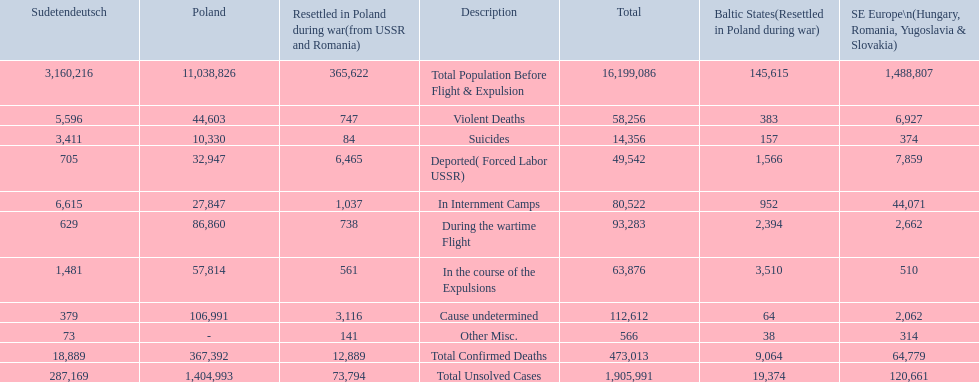What are all of the descriptions? Total Population Before Flight & Expulsion, Violent Deaths, Suicides, Deported( Forced Labor USSR), In Internment Camps, During the wartime Flight, In the course of the Expulsions, Cause undetermined, Other Misc., Total Confirmed Deaths, Total Unsolved Cases. What were their total number of deaths? 16,199,086, 58,256, 14,356, 49,542, 80,522, 93,283, 63,876, 112,612, 566, 473,013, 1,905,991. What about just from violent deaths? 58,256. 